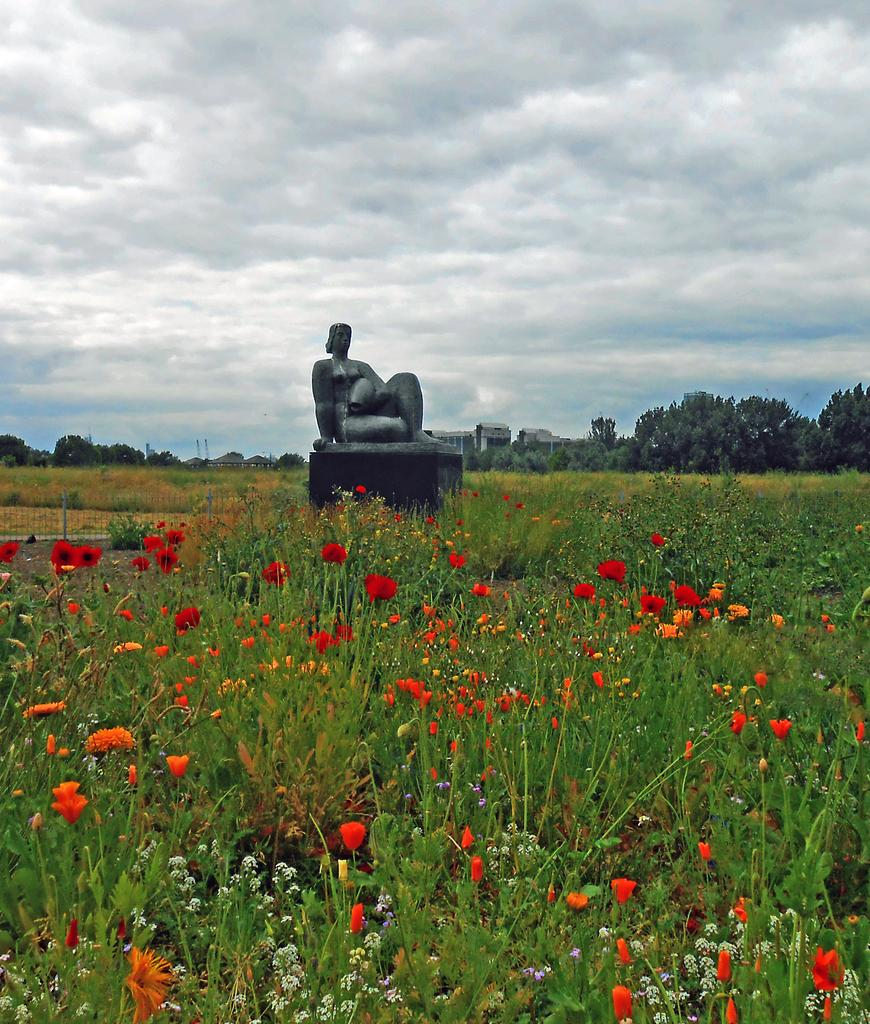What type of plants can be seen in the image? There are flower plants in the image. What is located on the path in the image? There is a statue on the path in the image. What is behind the statue? There is a fence behind the statue. What can be seen in the distance in the image? There is a building visible in the background, along with trees and a cloudy sky. What type of ink is being used to draw on the statue in the image? There is no ink or drawing present on the statue in the image. How much debt is visible on the building in the background of the image? There is no indication of debt on the building in the image; it is simply a visible structure in the background. 